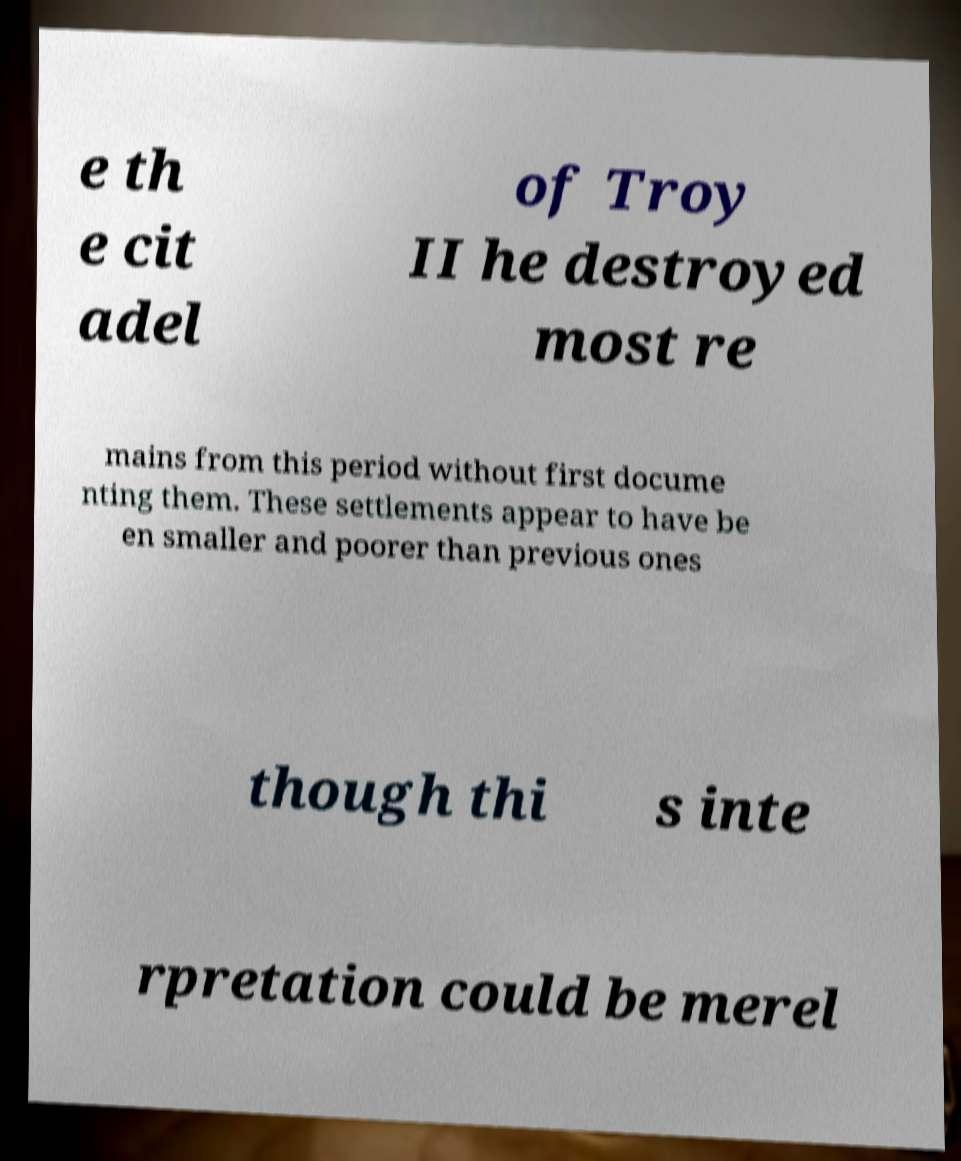Please identify and transcribe the text found in this image. e th e cit adel of Troy II he destroyed most re mains from this period without first docume nting them. These settlements appear to have be en smaller and poorer than previous ones though thi s inte rpretation could be merel 